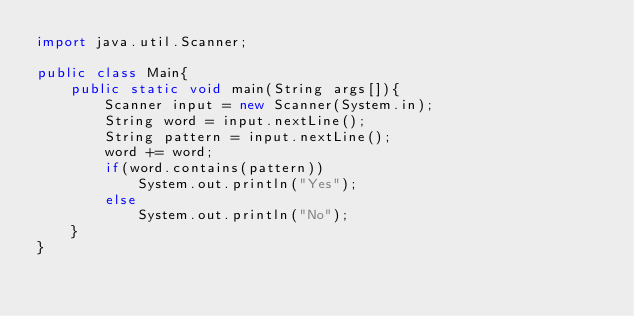<code> <loc_0><loc_0><loc_500><loc_500><_Java_>import java.util.Scanner;

public class Main{
    public static void main(String args[]){
        Scanner input = new Scanner(System.in);
        String word = input.nextLine();
        String pattern = input.nextLine();
        word += word;
        if(word.contains(pattern))
            System.out.println("Yes");
        else
            System.out.println("No");
    }
}
</code> 